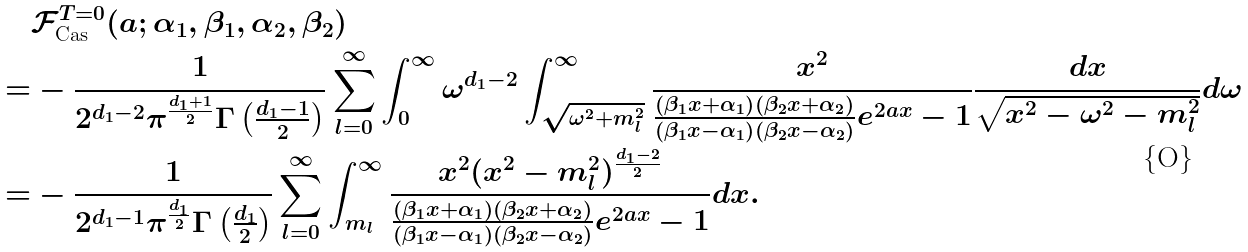<formula> <loc_0><loc_0><loc_500><loc_500>& \mathcal { F } _ { \text {Cas} } ^ { T = 0 } ( a ; \alpha _ { 1 } , \beta _ { 1 } , \alpha _ { 2 } , \beta _ { 2 } ) \\ = & - \frac { 1 } { 2 ^ { d _ { 1 } - 2 } \pi ^ { \frac { d _ { 1 } + 1 } { 2 } } \Gamma \left ( \frac { d _ { 1 } - 1 } { 2 } \right ) } \sum _ { l = 0 } ^ { \infty } \int _ { 0 } ^ { \infty } \omega ^ { d _ { 1 } - 2 } \int _ { \sqrt { \omega ^ { 2 } + m _ { l } ^ { 2 } } } ^ { \infty } \frac { x ^ { 2 } } { \frac { \left ( \beta _ { 1 } x + \alpha _ { 1 } \right ) \left ( \beta _ { 2 } x + \alpha _ { 2 } \right ) } { \left ( \beta _ { 1 } x - \alpha _ { 1 } \right ) \left ( \beta _ { 2 } x - \alpha _ { 2 } \right ) } e ^ { 2 a x } - 1 } \frac { d x } { \sqrt { x ^ { 2 } - \omega ^ { 2 } - m _ { l } ^ { 2 } } } d \omega \\ = & - \frac { 1 } { 2 ^ { d _ { 1 } - 1 } \pi ^ { \frac { d _ { 1 } } { 2 } } \Gamma \left ( \frac { d _ { 1 } } { 2 } \right ) } \sum _ { l = 0 } ^ { \infty } \int _ { m _ { l } } ^ { \infty } \frac { x ^ { 2 } ( x ^ { 2 } - m _ { l } ^ { 2 } ) ^ { \frac { d _ { 1 } - 2 } { 2 } } } { \frac { \left ( \beta _ { 1 } x + \alpha _ { 1 } \right ) \left ( \beta _ { 2 } x + \alpha _ { 2 } \right ) } { \left ( \beta _ { 1 } x - \alpha _ { 1 } \right ) \left ( \beta _ { 2 } x - \alpha _ { 2 } \right ) } e ^ { 2 a x } - 1 } d x .</formula> 